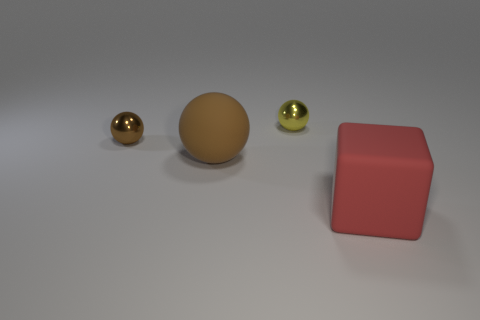Do the small metal thing that is in front of the yellow ball and the big matte sphere have the same color?
Your answer should be very brief. Yes. How many other objects are the same size as the red rubber block?
Make the answer very short. 1. Does the large sphere have the same material as the small yellow ball?
Your response must be concise. No. The large matte thing that is behind the big red matte cube to the right of the brown matte object is what color?
Offer a very short reply. Brown. What is the size of the yellow thing that is the same shape as the brown shiny object?
Provide a succinct answer. Small. There is a tiny shiny thing that is on the left side of the yellow thing to the right of the brown metallic object; what number of matte spheres are in front of it?
Make the answer very short. 1. Are there more metallic balls than tiny gray metal objects?
Provide a short and direct response. Yes. What number of large things are there?
Your response must be concise. 2. The metal object on the left side of the shiny object behind the shiny ball on the left side of the small yellow thing is what shape?
Give a very brief answer. Sphere. Are there fewer brown metal balls on the right side of the big brown ball than brown metallic objects behind the matte cube?
Offer a terse response. Yes. 